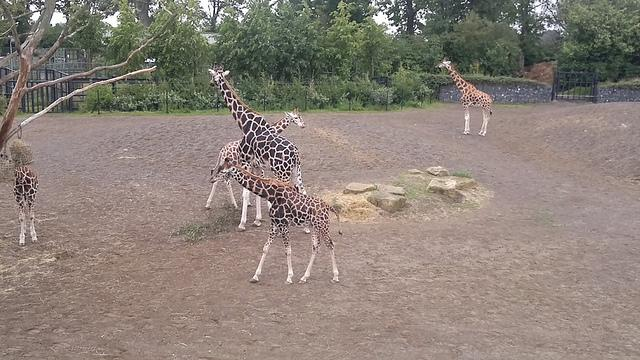What do these animals have?

Choices:
A) long necks
B) wings
C) horns
D) talons long necks 